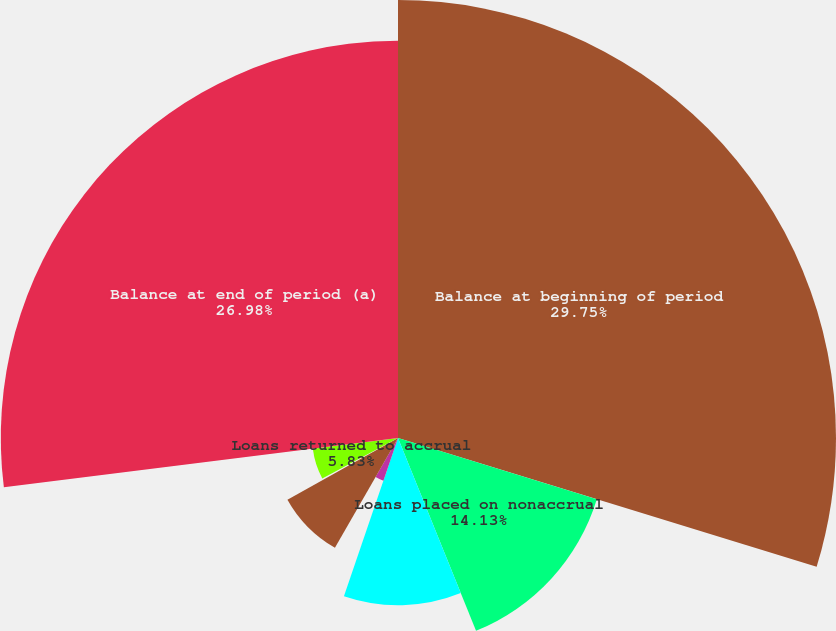Convert chart to OTSL. <chart><loc_0><loc_0><loc_500><loc_500><pie_chart><fcel>Balance at beginning of period<fcel>Loans placed on nonaccrual<fcel>Charge-offs<fcel>Loans sold<fcel>Payments<fcel>Transfers to OREO<fcel>Loans returned to accrual<fcel>Balance at end of period (a)<nl><fcel>29.75%<fcel>14.13%<fcel>11.36%<fcel>3.06%<fcel>8.6%<fcel>0.29%<fcel>5.83%<fcel>26.98%<nl></chart> 